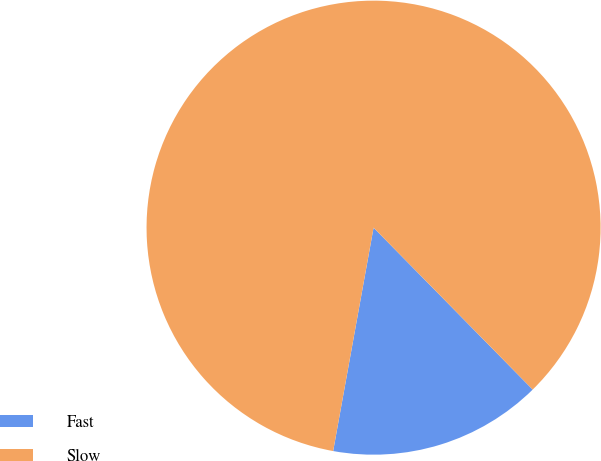<chart> <loc_0><loc_0><loc_500><loc_500><pie_chart><fcel>Fast<fcel>Slow<nl><fcel>15.21%<fcel>84.79%<nl></chart> 